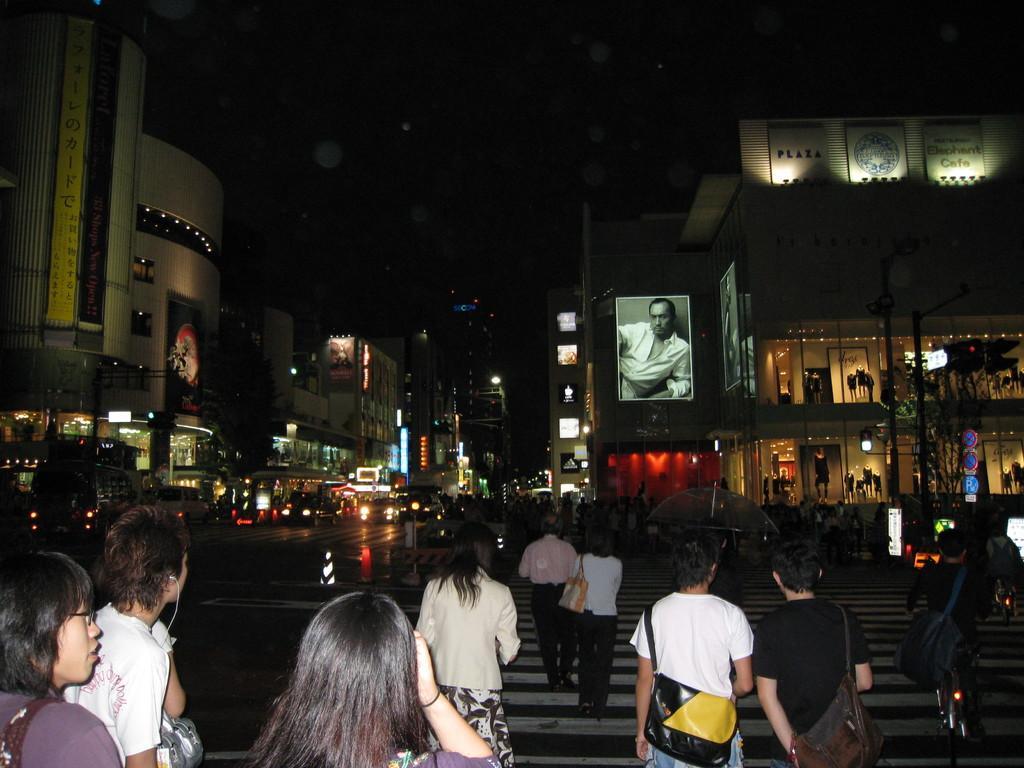Please provide a concise description of this image. In the foreground of this image, there are persons walking on the zebra crossing and an umbrella is holding by a person. In the background, there are buildings, banners, road, vehicles moving on the road, lights, sign boards, traffic signal pole and the dark sky. 